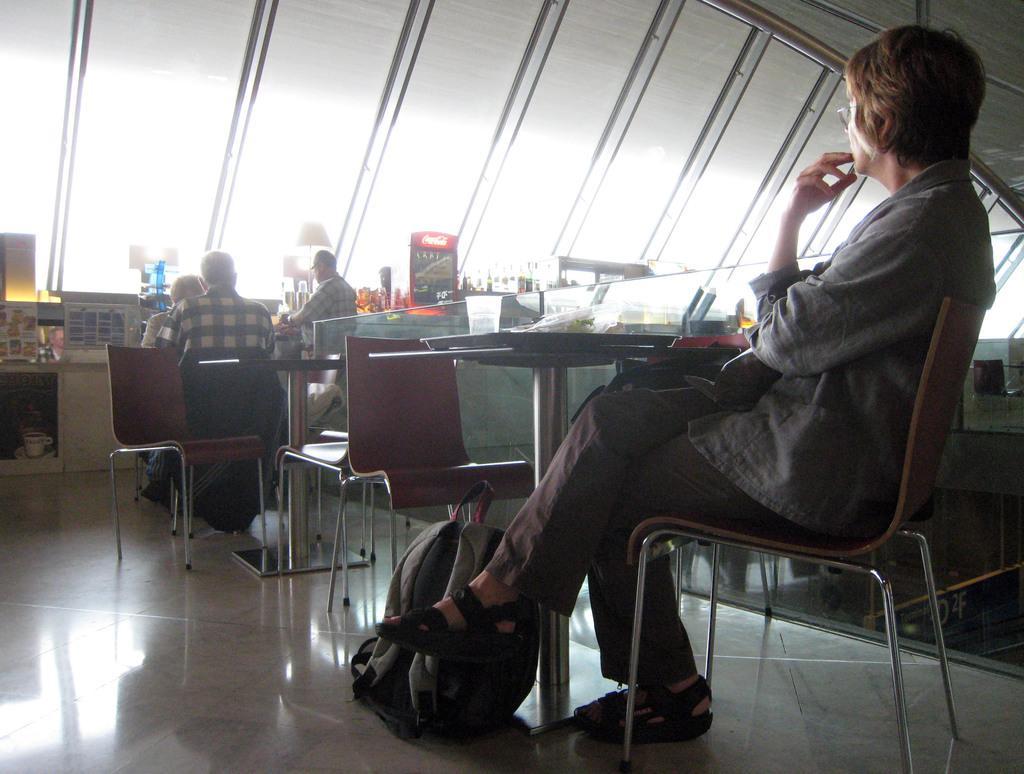Could you give a brief overview of what you see in this image? In this picture we can see a woman sitting on a chair in front of a table, there is a bag which is placed on a floor, in the background we can see two person sitting on chairs and also we can see lamps and some of the papers here, on the right side of the picture we can see glass. 